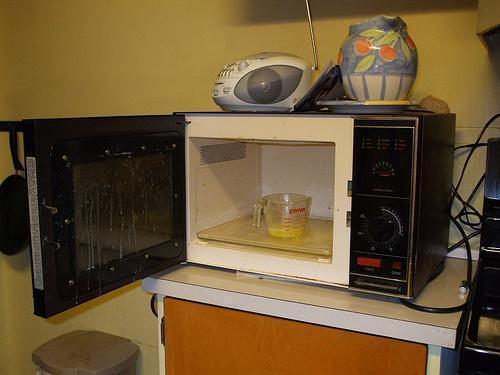How many microwaves are there?
Give a very brief answer. 1. 